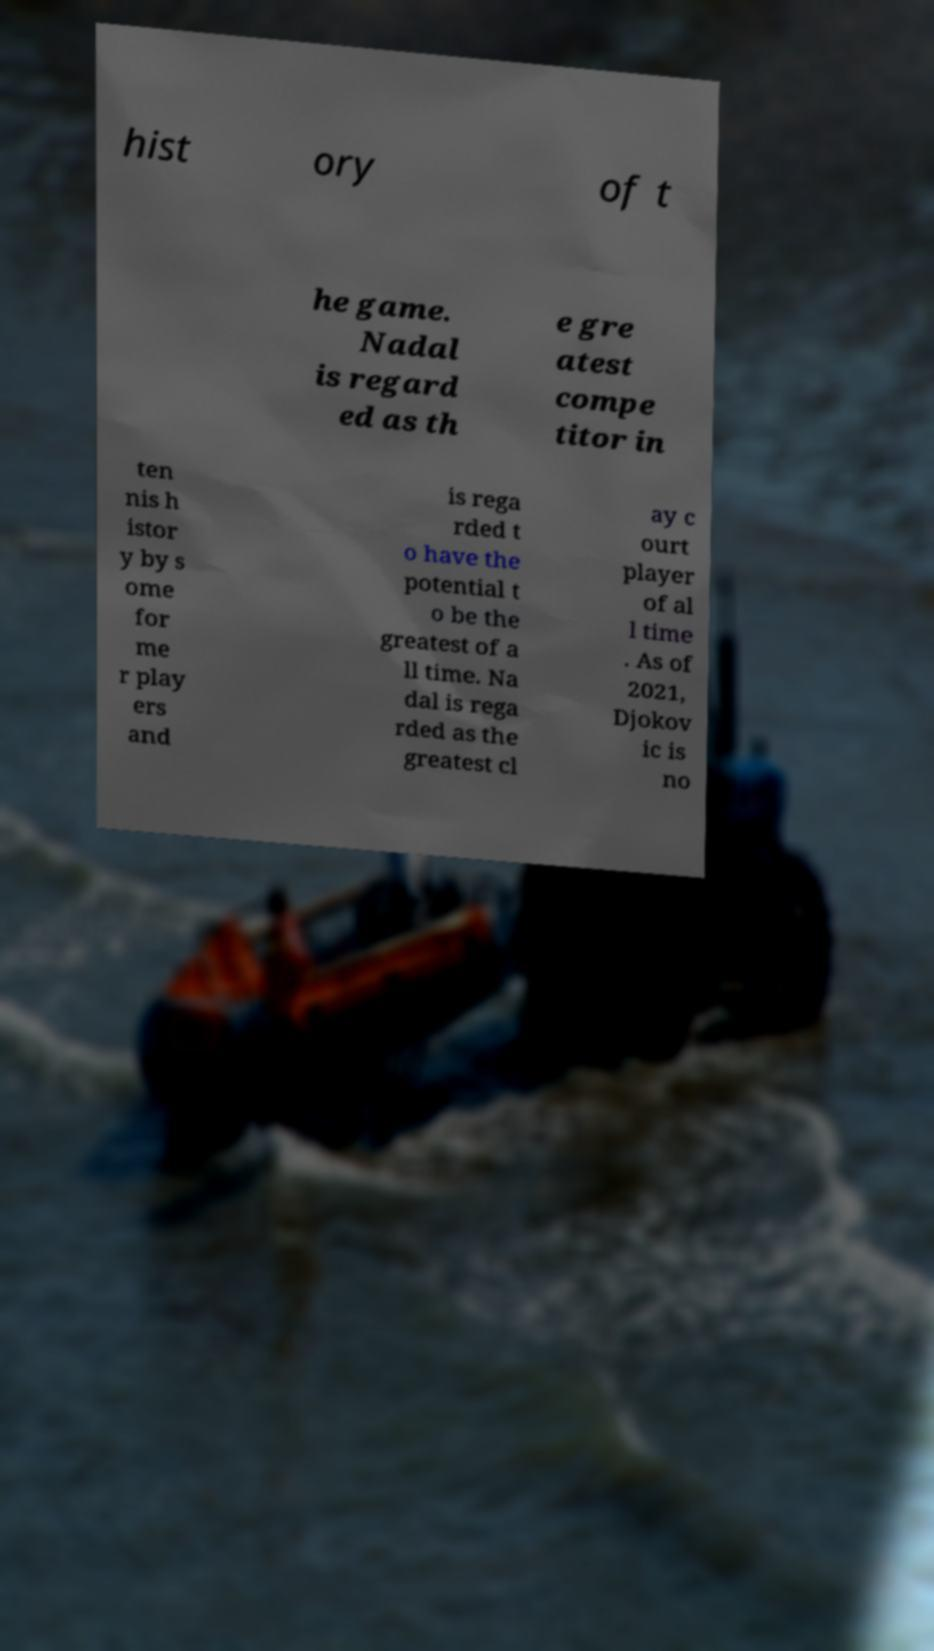Could you extract and type out the text from this image? hist ory of t he game. Nadal is regard ed as th e gre atest compe titor in ten nis h istor y by s ome for me r play ers and is rega rded t o have the potential t o be the greatest of a ll time. Na dal is rega rded as the greatest cl ay c ourt player of al l time . As of 2021, Djokov ic is no 